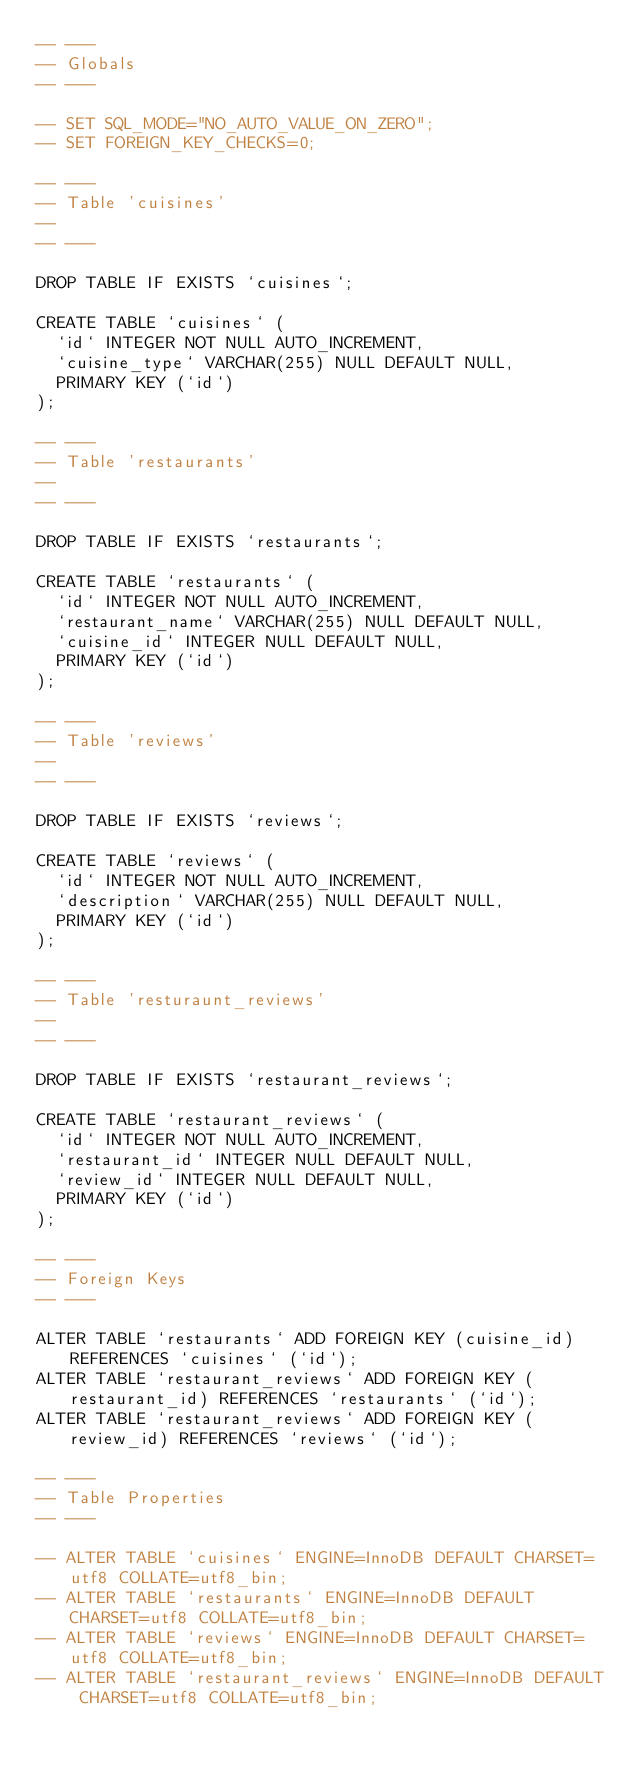<code> <loc_0><loc_0><loc_500><loc_500><_SQL_>-- ---
-- Globals
-- ---

-- SET SQL_MODE="NO_AUTO_VALUE_ON_ZERO";
-- SET FOREIGN_KEY_CHECKS=0;

-- ---
-- Table 'cuisines'
--
-- ---

DROP TABLE IF EXISTS `cuisines`;

CREATE TABLE `cuisines` (
  `id` INTEGER NOT NULL AUTO_INCREMENT,
  `cuisine_type` VARCHAR(255) NULL DEFAULT NULL,
  PRIMARY KEY (`id`)
);

-- ---
-- Table 'restaurants'
--
-- ---

DROP TABLE IF EXISTS `restaurants`;

CREATE TABLE `restaurants` (
  `id` INTEGER NOT NULL AUTO_INCREMENT,
  `restaurant_name` VARCHAR(255) NULL DEFAULT NULL,
  `cuisine_id` INTEGER NULL DEFAULT NULL,
  PRIMARY KEY (`id`)
);

-- ---
-- Table 'reviews'
--
-- ---

DROP TABLE IF EXISTS `reviews`;

CREATE TABLE `reviews` (
  `id` INTEGER NOT NULL AUTO_INCREMENT,
  `description` VARCHAR(255) NULL DEFAULT NULL,
  PRIMARY KEY (`id`)
);

-- ---
-- Table 'resturaunt_reviews'
--
-- ---

DROP TABLE IF EXISTS `restaurant_reviews`;

CREATE TABLE `restaurant_reviews` (
  `id` INTEGER NOT NULL AUTO_INCREMENT,
  `restaurant_id` INTEGER NULL DEFAULT NULL,
  `review_id` INTEGER NULL DEFAULT NULL,
  PRIMARY KEY (`id`)
);

-- ---
-- Foreign Keys
-- ---

ALTER TABLE `restaurants` ADD FOREIGN KEY (cuisine_id) REFERENCES `cuisines` (`id`);
ALTER TABLE `restaurant_reviews` ADD FOREIGN KEY (restaurant_id) REFERENCES `restaurants` (`id`);
ALTER TABLE `restaurant_reviews` ADD FOREIGN KEY (review_id) REFERENCES `reviews` (`id`);

-- ---
-- Table Properties
-- ---

-- ALTER TABLE `cuisines` ENGINE=InnoDB DEFAULT CHARSET=utf8 COLLATE=utf8_bin;
-- ALTER TABLE `restaurants` ENGINE=InnoDB DEFAULT CHARSET=utf8 COLLATE=utf8_bin;
-- ALTER TABLE `reviews` ENGINE=InnoDB DEFAULT CHARSET=utf8 COLLATE=utf8_bin;
-- ALTER TABLE `restaurant_reviews` ENGINE=InnoDB DEFAULT CHARSET=utf8 COLLATE=utf8_bin;
</code> 